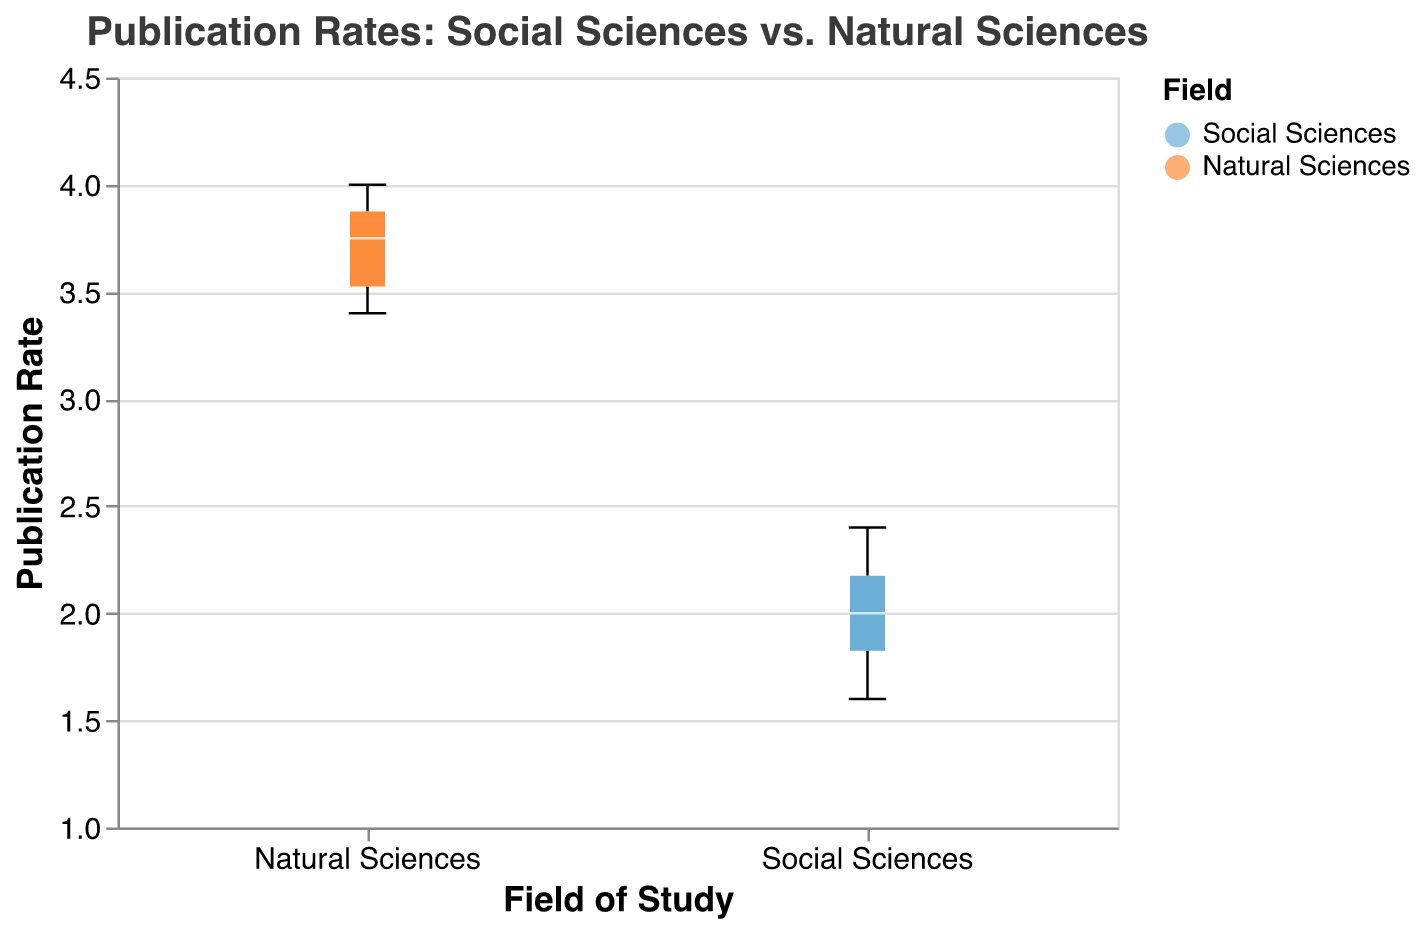What is the title of the figure? The title is displayed at the top of the figure. It states "Publication Rates: Social Sciences vs. Natural Sciences".
Answer: Publication Rates: Social Sciences vs. Natural Sciences Which group has a higher median publication rate? By comparing the median lines inside the box plots, which are colored white, we see that the median for the Natural Sciences group is higher than the median for the Social Sciences group.
Answer: Natural Sciences What range does the y-axis cover? The y-axis, which represents the publication rate, spans from 1 to 4.5, as indicated by the scale on the plot.
Answer: 1 to 4.5 How many universities are represented in each group? Each group consists of 10 data points, suggesting that 10 universities are represented in both Social Sciences and Natural Sciences.
Answer: 10 Which group has the wider range of publication rates? The range can be determined by comparing the distances from the top whisker to the bottom whisker of each box plot. The Natural Sciences group has a wider range, from approximately 3.4 to 4.0, compared to the Social Sciences group's range from approximately 1.6 to 2.4.
Answer: Natural Sciences What is the maximum publication rate in the Natural Sciences group? The maximum publication rate in the Natural Sciences group corresponds to the top whisker of the box plot, which is 4.0.
Answer: 4.0 By how much does the median publication rate for Natural Sciences exceed that of Social Sciences? The median value for the Social Sciences group is approximately 2.0, and for the Natural Sciences group, it is approximately 3.7. Therefore, the difference is 3.7 - 2.0 = 1.7.
Answer: 1.7 What color is used to represent the Social Sciences group? The color corresponding to the Social Sciences group in the plot is a shade of blue.
Answer: Blue What is the interquartile range (IQR) for the Social Sciences group? The IQR is the range between the first (Q1) and third quartiles (Q3). For the Social Sciences group, Q1 is approximately 1.8, and Q3 is approximately 2.2. Thus, the IQR is 2.2 - 1.8 = 0.4.
Answer: 0.4 Is there any overlap in the publication rates of the two groups? By observing the box plots, the top whisker of the Social Sciences group and the bottom whisker of the Natural Sciences group both cover a publication rate of 3.4 to 3.5, thus there is an overlap.
Answer: Yes 